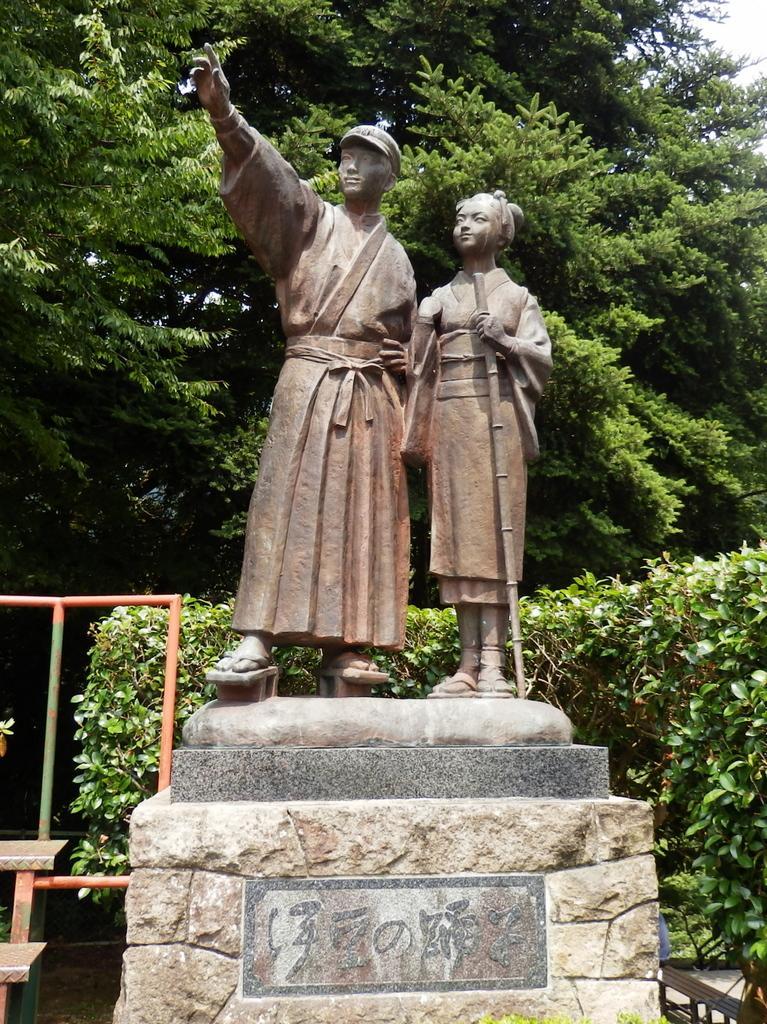Could you give a brief overview of what you see in this image? In the picture we can see two human sculptures on the stone and behind it, we can see some plants, and a part of the railing and behind it we can see the tree and a part of the sky. 